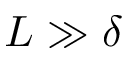<formula> <loc_0><loc_0><loc_500><loc_500>L \gg \delta</formula> 